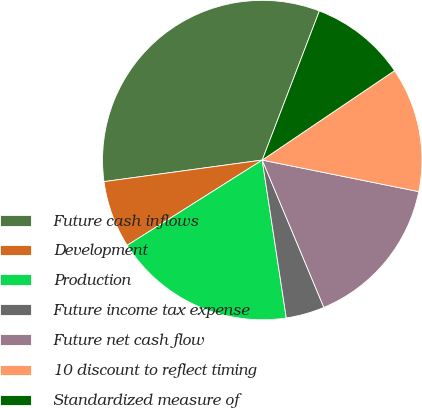<chart> <loc_0><loc_0><loc_500><loc_500><pie_chart><fcel>Future cash inflows<fcel>Development<fcel>Production<fcel>Future income tax expense<fcel>Future net cash flow<fcel>10 discount to reflect timing<fcel>Standardized measure of<nl><fcel>32.98%<fcel>6.81%<fcel>18.44%<fcel>3.9%<fcel>15.53%<fcel>12.62%<fcel>9.72%<nl></chart> 